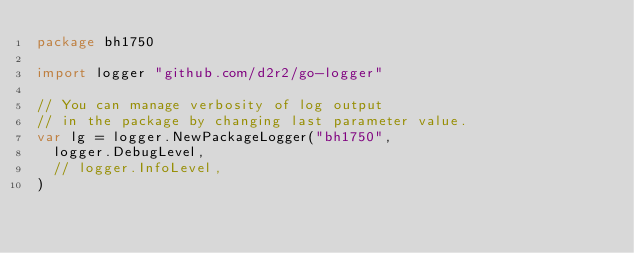Convert code to text. <code><loc_0><loc_0><loc_500><loc_500><_Go_>package bh1750

import logger "github.com/d2r2/go-logger"

// You can manage verbosity of log output
// in the package by changing last parameter value.
var lg = logger.NewPackageLogger("bh1750",
	logger.DebugLevel,
	// logger.InfoLevel,
)
</code> 